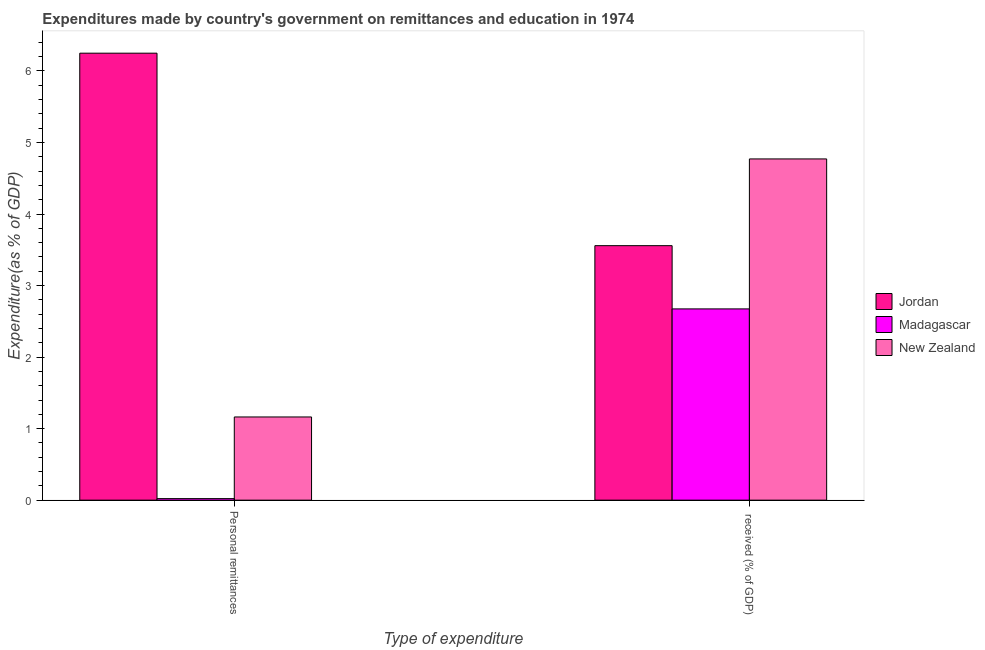How many groups of bars are there?
Keep it short and to the point. 2. How many bars are there on the 1st tick from the right?
Your answer should be very brief. 3. What is the label of the 2nd group of bars from the left?
Ensure brevity in your answer.   received (% of GDP). What is the expenditure in personal remittances in New Zealand?
Give a very brief answer. 1.16. Across all countries, what is the maximum expenditure in personal remittances?
Offer a terse response. 6.25. Across all countries, what is the minimum expenditure in education?
Ensure brevity in your answer.  2.67. In which country was the expenditure in personal remittances maximum?
Your answer should be compact. Jordan. In which country was the expenditure in education minimum?
Keep it short and to the point. Madagascar. What is the total expenditure in education in the graph?
Offer a terse response. 11. What is the difference between the expenditure in education in Jordan and that in Madagascar?
Ensure brevity in your answer.  0.88. What is the difference between the expenditure in education in Jordan and the expenditure in personal remittances in New Zealand?
Your response must be concise. 2.39. What is the average expenditure in personal remittances per country?
Provide a succinct answer. 2.48. What is the difference between the expenditure in personal remittances and expenditure in education in Madagascar?
Your answer should be very brief. -2.65. In how many countries, is the expenditure in personal remittances greater than 4.4 %?
Offer a very short reply. 1. What is the ratio of the expenditure in personal remittances in Madagascar to that in New Zealand?
Your answer should be very brief. 0.02. Is the expenditure in personal remittances in Madagascar less than that in Jordan?
Make the answer very short. Yes. What does the 3rd bar from the left in  received (% of GDP) represents?
Your response must be concise. New Zealand. What does the 1st bar from the right in Personal remittances represents?
Your response must be concise. New Zealand. How many bars are there?
Your answer should be very brief. 6. Are all the bars in the graph horizontal?
Offer a very short reply. No. How many countries are there in the graph?
Give a very brief answer. 3. Are the values on the major ticks of Y-axis written in scientific E-notation?
Ensure brevity in your answer.  No. Does the graph contain grids?
Provide a short and direct response. No. Where does the legend appear in the graph?
Your response must be concise. Center right. How are the legend labels stacked?
Provide a short and direct response. Vertical. What is the title of the graph?
Your answer should be very brief. Expenditures made by country's government on remittances and education in 1974. What is the label or title of the X-axis?
Offer a very short reply. Type of expenditure. What is the label or title of the Y-axis?
Your answer should be compact. Expenditure(as % of GDP). What is the Expenditure(as % of GDP) of Jordan in Personal remittances?
Give a very brief answer. 6.25. What is the Expenditure(as % of GDP) of Madagascar in Personal remittances?
Provide a short and direct response. 0.02. What is the Expenditure(as % of GDP) of New Zealand in Personal remittances?
Offer a very short reply. 1.16. What is the Expenditure(as % of GDP) in Jordan in  received (% of GDP)?
Offer a terse response. 3.56. What is the Expenditure(as % of GDP) in Madagascar in  received (% of GDP)?
Your answer should be compact. 2.67. What is the Expenditure(as % of GDP) of New Zealand in  received (% of GDP)?
Offer a very short reply. 4.77. Across all Type of expenditure, what is the maximum Expenditure(as % of GDP) in Jordan?
Your answer should be very brief. 6.25. Across all Type of expenditure, what is the maximum Expenditure(as % of GDP) in Madagascar?
Ensure brevity in your answer.  2.67. Across all Type of expenditure, what is the maximum Expenditure(as % of GDP) in New Zealand?
Provide a succinct answer. 4.77. Across all Type of expenditure, what is the minimum Expenditure(as % of GDP) in Jordan?
Make the answer very short. 3.56. Across all Type of expenditure, what is the minimum Expenditure(as % of GDP) of Madagascar?
Offer a very short reply. 0.02. Across all Type of expenditure, what is the minimum Expenditure(as % of GDP) in New Zealand?
Provide a short and direct response. 1.16. What is the total Expenditure(as % of GDP) of Jordan in the graph?
Your answer should be compact. 9.81. What is the total Expenditure(as % of GDP) of Madagascar in the graph?
Provide a short and direct response. 2.7. What is the total Expenditure(as % of GDP) in New Zealand in the graph?
Provide a short and direct response. 5.93. What is the difference between the Expenditure(as % of GDP) in Jordan in Personal remittances and that in  received (% of GDP)?
Ensure brevity in your answer.  2.69. What is the difference between the Expenditure(as % of GDP) in Madagascar in Personal remittances and that in  received (% of GDP)?
Your answer should be compact. -2.65. What is the difference between the Expenditure(as % of GDP) in New Zealand in Personal remittances and that in  received (% of GDP)?
Make the answer very short. -3.61. What is the difference between the Expenditure(as % of GDP) in Jordan in Personal remittances and the Expenditure(as % of GDP) in Madagascar in  received (% of GDP)?
Your response must be concise. 3.57. What is the difference between the Expenditure(as % of GDP) in Jordan in Personal remittances and the Expenditure(as % of GDP) in New Zealand in  received (% of GDP)?
Keep it short and to the point. 1.48. What is the difference between the Expenditure(as % of GDP) in Madagascar in Personal remittances and the Expenditure(as % of GDP) in New Zealand in  received (% of GDP)?
Your answer should be compact. -4.75. What is the average Expenditure(as % of GDP) of Jordan per Type of expenditure?
Offer a terse response. 4.9. What is the average Expenditure(as % of GDP) of Madagascar per Type of expenditure?
Make the answer very short. 1.35. What is the average Expenditure(as % of GDP) in New Zealand per Type of expenditure?
Offer a terse response. 2.97. What is the difference between the Expenditure(as % of GDP) in Jordan and Expenditure(as % of GDP) in Madagascar in Personal remittances?
Offer a terse response. 6.23. What is the difference between the Expenditure(as % of GDP) of Jordan and Expenditure(as % of GDP) of New Zealand in Personal remittances?
Offer a terse response. 5.09. What is the difference between the Expenditure(as % of GDP) of Madagascar and Expenditure(as % of GDP) of New Zealand in Personal remittances?
Your answer should be compact. -1.14. What is the difference between the Expenditure(as % of GDP) in Jordan and Expenditure(as % of GDP) in Madagascar in  received (% of GDP)?
Your response must be concise. 0.88. What is the difference between the Expenditure(as % of GDP) of Jordan and Expenditure(as % of GDP) of New Zealand in  received (% of GDP)?
Provide a succinct answer. -1.21. What is the difference between the Expenditure(as % of GDP) in Madagascar and Expenditure(as % of GDP) in New Zealand in  received (% of GDP)?
Provide a short and direct response. -2.1. What is the ratio of the Expenditure(as % of GDP) in Jordan in Personal remittances to that in  received (% of GDP)?
Provide a succinct answer. 1.76. What is the ratio of the Expenditure(as % of GDP) of Madagascar in Personal remittances to that in  received (% of GDP)?
Offer a very short reply. 0.01. What is the ratio of the Expenditure(as % of GDP) of New Zealand in Personal remittances to that in  received (% of GDP)?
Provide a succinct answer. 0.24. What is the difference between the highest and the second highest Expenditure(as % of GDP) of Jordan?
Provide a short and direct response. 2.69. What is the difference between the highest and the second highest Expenditure(as % of GDP) in Madagascar?
Give a very brief answer. 2.65. What is the difference between the highest and the second highest Expenditure(as % of GDP) of New Zealand?
Ensure brevity in your answer.  3.61. What is the difference between the highest and the lowest Expenditure(as % of GDP) in Jordan?
Your response must be concise. 2.69. What is the difference between the highest and the lowest Expenditure(as % of GDP) of Madagascar?
Keep it short and to the point. 2.65. What is the difference between the highest and the lowest Expenditure(as % of GDP) in New Zealand?
Your answer should be very brief. 3.61. 